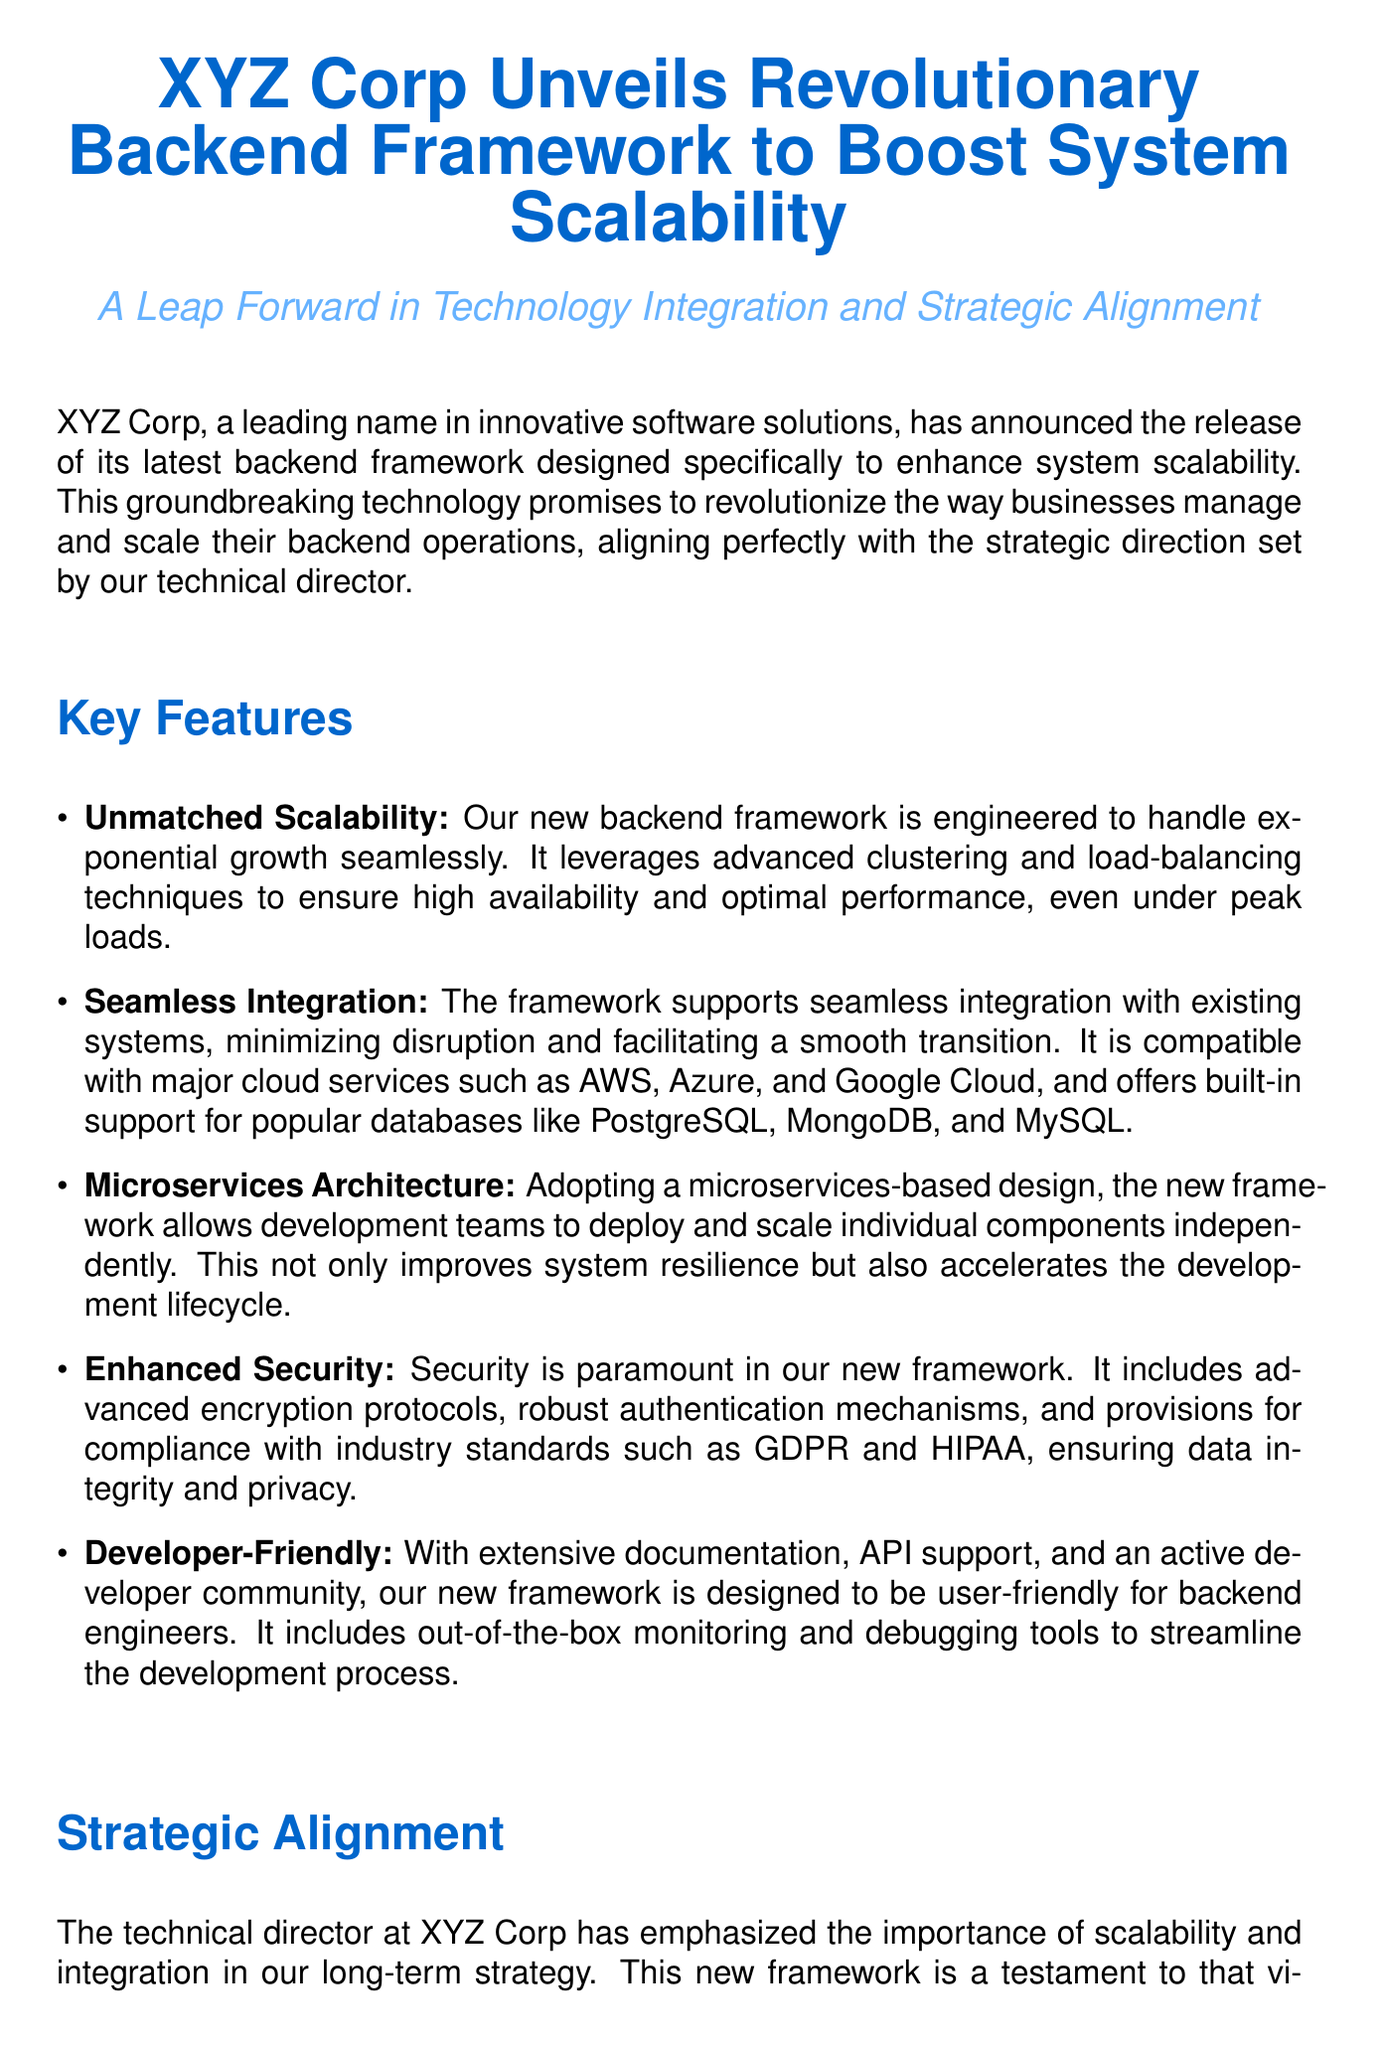What is the name of the company that announced the new framework? The document states that XYZ Corp announced the new framework.
Answer: XYZ Corp What is a key feature of the new backend framework? The document lists unmatched scalability as a key feature of the framework.
Answer: Unmatched Scalability Which cloud services is the framework compatible with? The document mentions AWS, Azure, and Google Cloud as compatible cloud services.
Answer: AWS, Azure, Google Cloud What does the new backend framework adopt in its architecture? The document specifies that the framework adopts a microservices-based design.
Answer: Microservices Architecture What does the technical director emphasize in the company's long-term strategy? The document indicates that scalability and integration are emphasized by the technical director.
Answer: Scalability and Integration What is one of the future plans for the backend framework? The document states that XYZ Corp plans to incorporate AI-driven analytics as a future feature.
Answer: AI-driven analytics How does the new framework ensure data integrity and privacy? The document explains that the framework includes advanced encryption protocols and robust authentication mechanisms.
Answer: Advanced encryption protocols, robust authentication mechanisms What is the contact email provided for XYZ Corp? The document lists press@xyz-corp.com as the contact email.
Answer: press@xyz-corp.com What is a benefit of adopting the new backend framework mentioned in the document? The document notes that the new framework improves system resilience as a benefit of its adoption.
Answer: Improves system resilience 